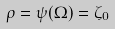<formula> <loc_0><loc_0><loc_500><loc_500>\rho = \psi ( \Omega ) = \zeta _ { 0 }</formula> 